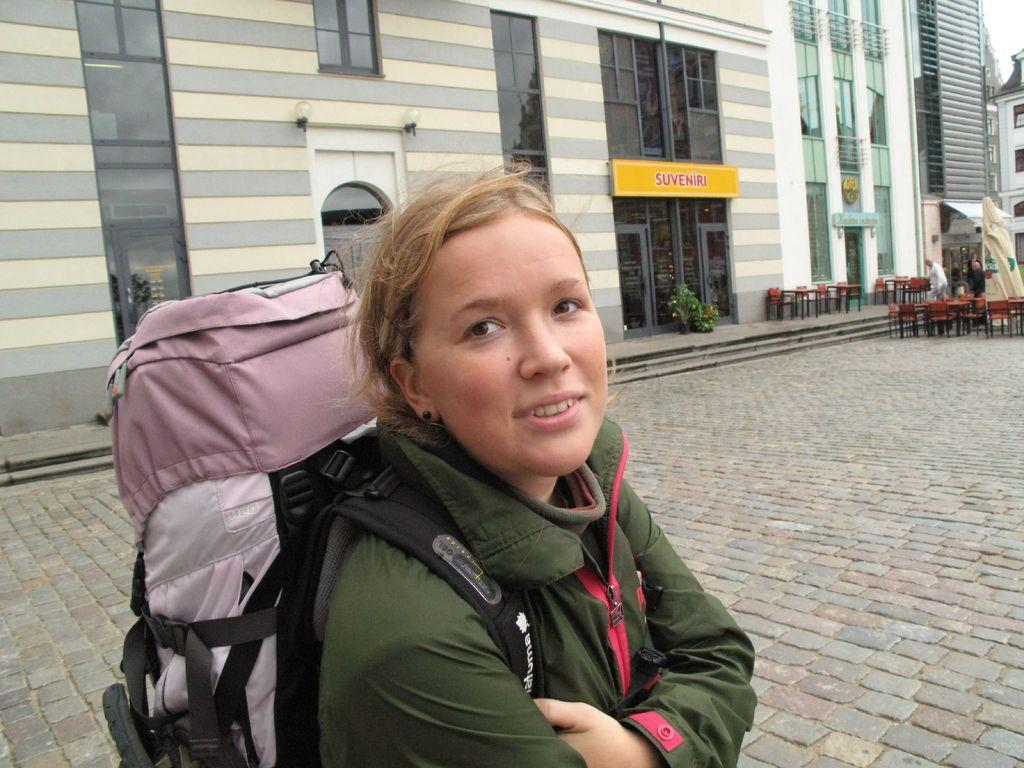Provide a one-sentence caption for the provided image. Girl with a tall backpack on her stnading in front of Suvveniri. 